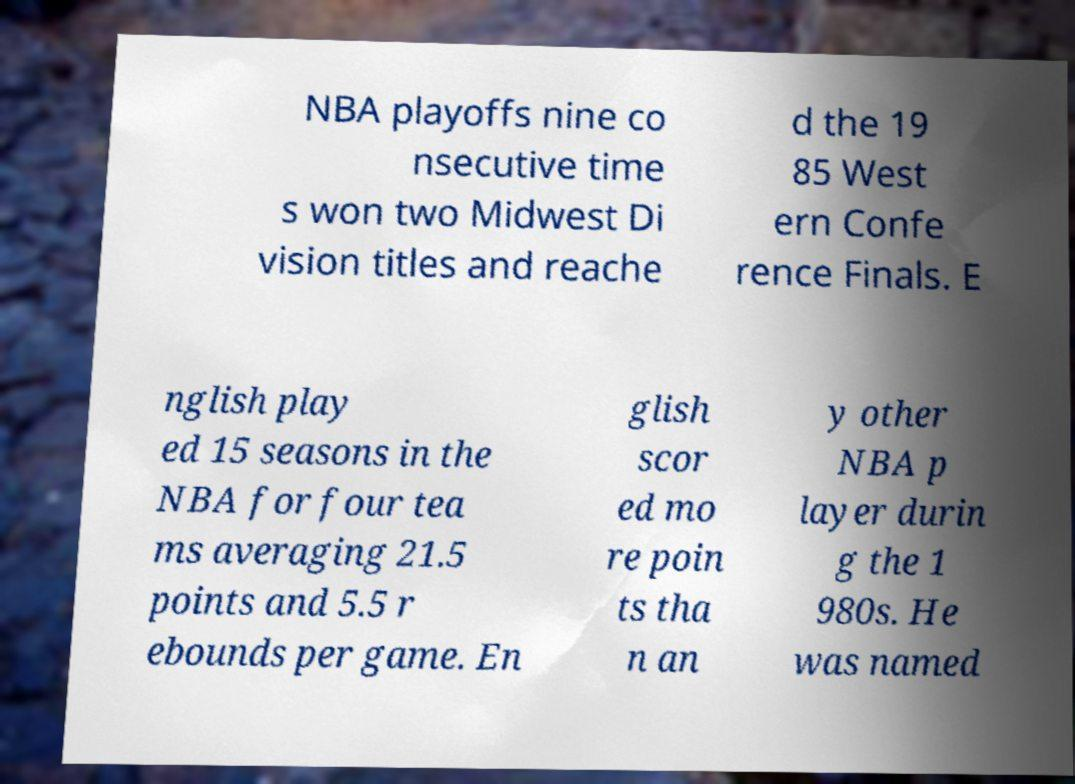I need the written content from this picture converted into text. Can you do that? NBA playoffs nine co nsecutive time s won two Midwest Di vision titles and reache d the 19 85 West ern Confe rence Finals. E nglish play ed 15 seasons in the NBA for four tea ms averaging 21.5 points and 5.5 r ebounds per game. En glish scor ed mo re poin ts tha n an y other NBA p layer durin g the 1 980s. He was named 